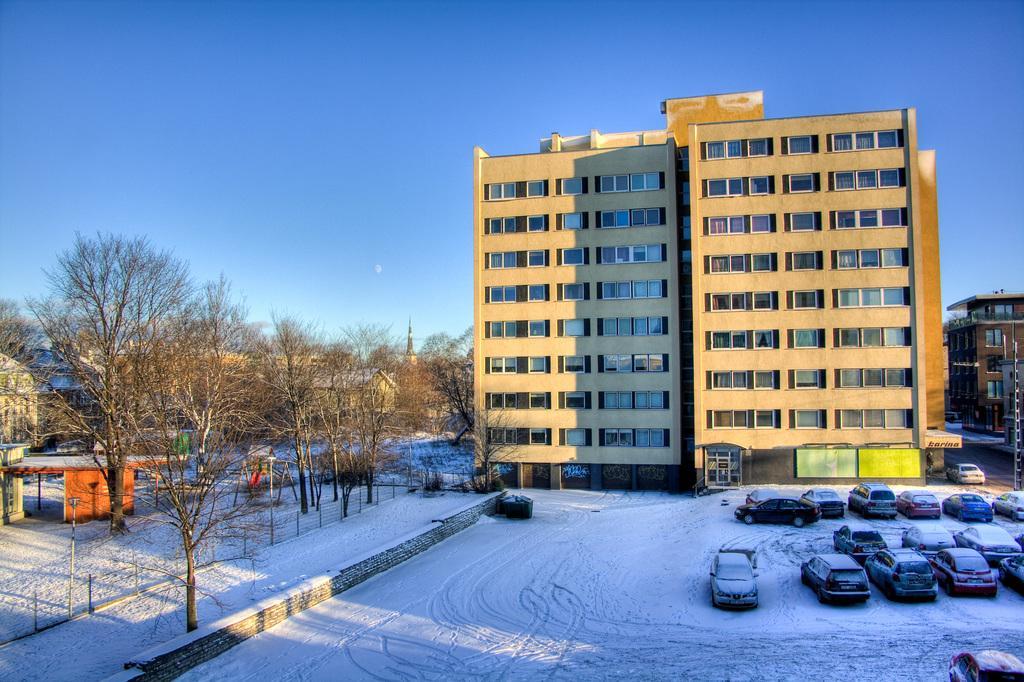In one or two sentences, can you explain what this image depicts? In this picture I can see buildings and few cars parked and I can see trees and snow and I can see a blue sky. 